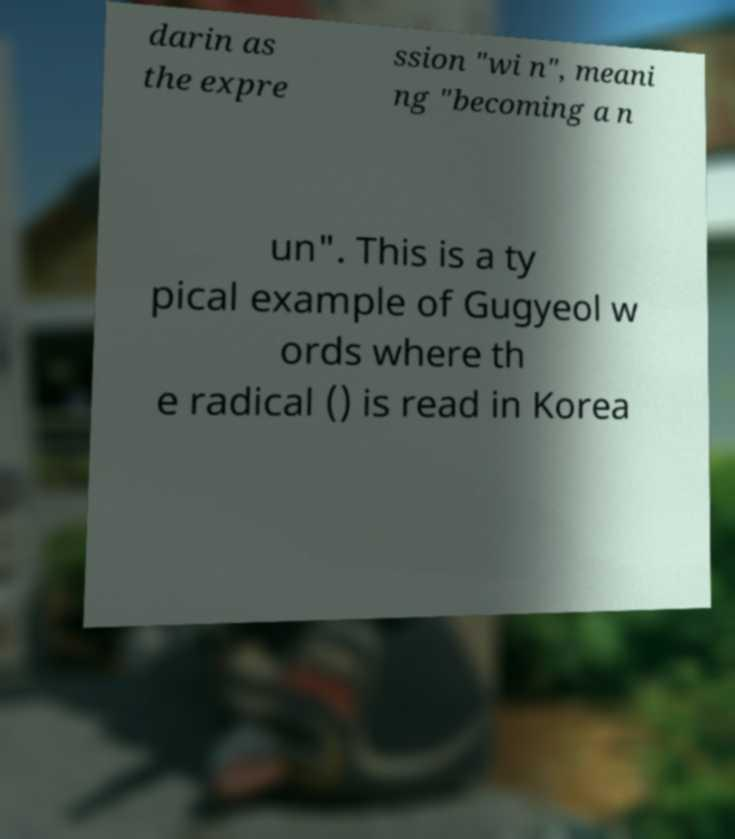For documentation purposes, I need the text within this image transcribed. Could you provide that? darin as the expre ssion "wi n", meani ng "becoming a n un". This is a ty pical example of Gugyeol w ords where th e radical () is read in Korea 